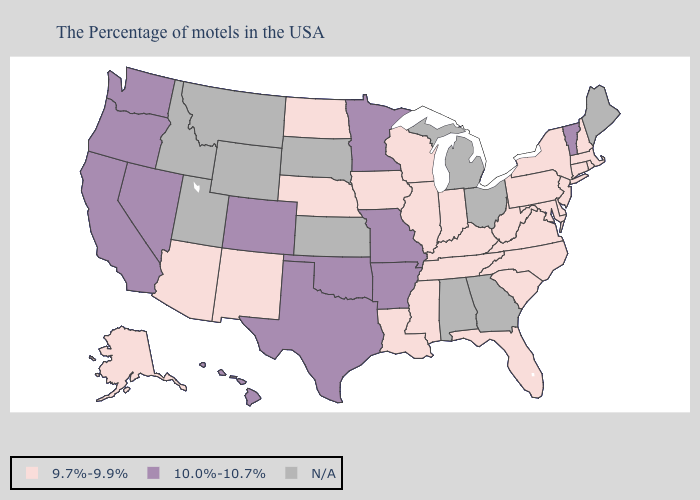Name the states that have a value in the range N/A?
Keep it brief. Maine, Ohio, Georgia, Michigan, Alabama, Kansas, South Dakota, Wyoming, Utah, Montana, Idaho. Does the map have missing data?
Write a very short answer. Yes. Among the states that border Massachusetts , which have the lowest value?
Keep it brief. Rhode Island, New Hampshire, Connecticut, New York. Which states hav the highest value in the South?
Short answer required. Arkansas, Oklahoma, Texas. What is the value of Connecticut?
Short answer required. 9.7%-9.9%. Is the legend a continuous bar?
Write a very short answer. No. Name the states that have a value in the range 10.0%-10.7%?
Write a very short answer. Vermont, Missouri, Arkansas, Minnesota, Oklahoma, Texas, Colorado, Nevada, California, Washington, Oregon, Hawaii. Does Massachusetts have the lowest value in the USA?
Give a very brief answer. Yes. Name the states that have a value in the range N/A?
Be succinct. Maine, Ohio, Georgia, Michigan, Alabama, Kansas, South Dakota, Wyoming, Utah, Montana, Idaho. What is the highest value in states that border Connecticut?
Give a very brief answer. 9.7%-9.9%. Name the states that have a value in the range 10.0%-10.7%?
Answer briefly. Vermont, Missouri, Arkansas, Minnesota, Oklahoma, Texas, Colorado, Nevada, California, Washington, Oregon, Hawaii. What is the lowest value in the USA?
Quick response, please. 9.7%-9.9%. What is the lowest value in states that border Wyoming?
Be succinct. 9.7%-9.9%. 